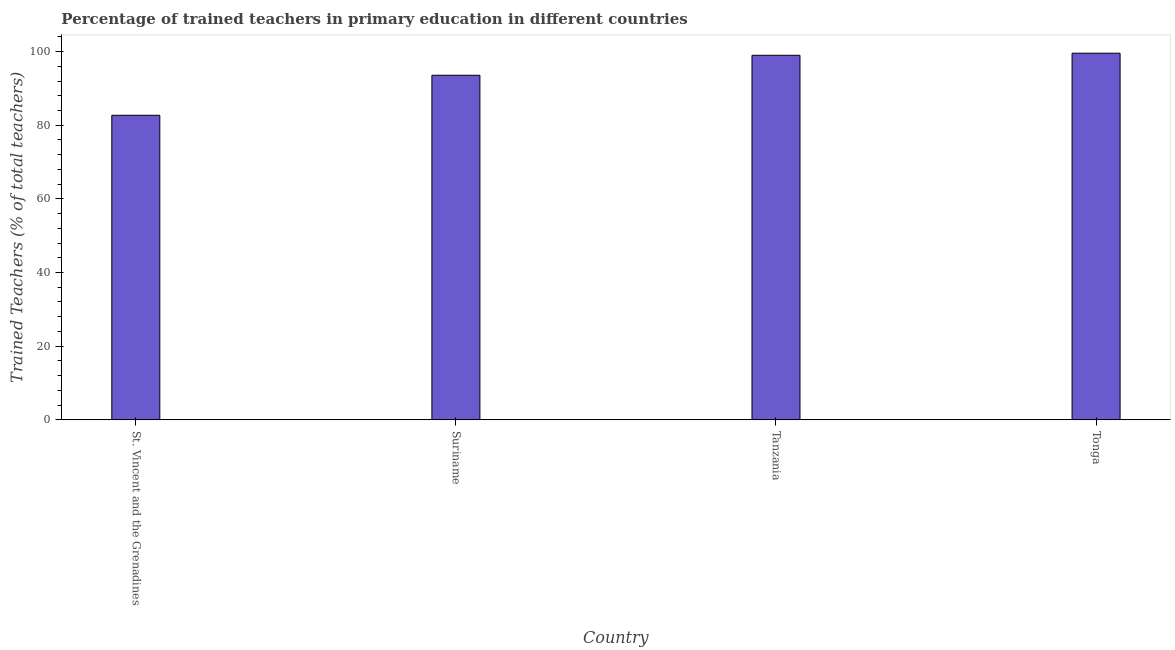What is the title of the graph?
Provide a succinct answer. Percentage of trained teachers in primary education in different countries. What is the label or title of the X-axis?
Give a very brief answer. Country. What is the label or title of the Y-axis?
Your answer should be very brief. Trained Teachers (% of total teachers). What is the percentage of trained teachers in Suriname?
Give a very brief answer. 93.56. Across all countries, what is the maximum percentage of trained teachers?
Your answer should be compact. 99.55. Across all countries, what is the minimum percentage of trained teachers?
Give a very brief answer. 82.7. In which country was the percentage of trained teachers maximum?
Your response must be concise. Tonga. In which country was the percentage of trained teachers minimum?
Provide a succinct answer. St. Vincent and the Grenadines. What is the sum of the percentage of trained teachers?
Offer a terse response. 374.8. What is the difference between the percentage of trained teachers in St. Vincent and the Grenadines and Suriname?
Offer a terse response. -10.87. What is the average percentage of trained teachers per country?
Offer a terse response. 93.7. What is the median percentage of trained teachers?
Your response must be concise. 96.27. In how many countries, is the percentage of trained teachers greater than 40 %?
Offer a very short reply. 4. What is the ratio of the percentage of trained teachers in St. Vincent and the Grenadines to that in Tonga?
Ensure brevity in your answer.  0.83. What is the difference between the highest and the second highest percentage of trained teachers?
Your response must be concise. 0.57. What is the difference between the highest and the lowest percentage of trained teachers?
Ensure brevity in your answer.  16.86. Are all the bars in the graph horizontal?
Make the answer very short. No. How many countries are there in the graph?
Your answer should be compact. 4. Are the values on the major ticks of Y-axis written in scientific E-notation?
Your answer should be very brief. No. What is the Trained Teachers (% of total teachers) in St. Vincent and the Grenadines?
Provide a short and direct response. 82.7. What is the Trained Teachers (% of total teachers) of Suriname?
Your answer should be very brief. 93.56. What is the Trained Teachers (% of total teachers) of Tanzania?
Keep it short and to the point. 98.99. What is the Trained Teachers (% of total teachers) of Tonga?
Provide a short and direct response. 99.55. What is the difference between the Trained Teachers (% of total teachers) in St. Vincent and the Grenadines and Suriname?
Provide a succinct answer. -10.87. What is the difference between the Trained Teachers (% of total teachers) in St. Vincent and the Grenadines and Tanzania?
Your response must be concise. -16.29. What is the difference between the Trained Teachers (% of total teachers) in St. Vincent and the Grenadines and Tonga?
Your answer should be very brief. -16.86. What is the difference between the Trained Teachers (% of total teachers) in Suriname and Tanzania?
Keep it short and to the point. -5.42. What is the difference between the Trained Teachers (% of total teachers) in Suriname and Tonga?
Your answer should be compact. -5.99. What is the difference between the Trained Teachers (% of total teachers) in Tanzania and Tonga?
Your response must be concise. -0.57. What is the ratio of the Trained Teachers (% of total teachers) in St. Vincent and the Grenadines to that in Suriname?
Make the answer very short. 0.88. What is the ratio of the Trained Teachers (% of total teachers) in St. Vincent and the Grenadines to that in Tanzania?
Offer a very short reply. 0.83. What is the ratio of the Trained Teachers (% of total teachers) in St. Vincent and the Grenadines to that in Tonga?
Provide a short and direct response. 0.83. What is the ratio of the Trained Teachers (% of total teachers) in Suriname to that in Tanzania?
Keep it short and to the point. 0.94. What is the ratio of the Trained Teachers (% of total teachers) in Suriname to that in Tonga?
Make the answer very short. 0.94. What is the ratio of the Trained Teachers (% of total teachers) in Tanzania to that in Tonga?
Provide a short and direct response. 0.99. 